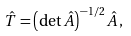Convert formula to latex. <formula><loc_0><loc_0><loc_500><loc_500>\hat { T } = \left ( \det \hat { A } \right ) ^ { - 1 / 2 } \hat { A } \, ,</formula> 